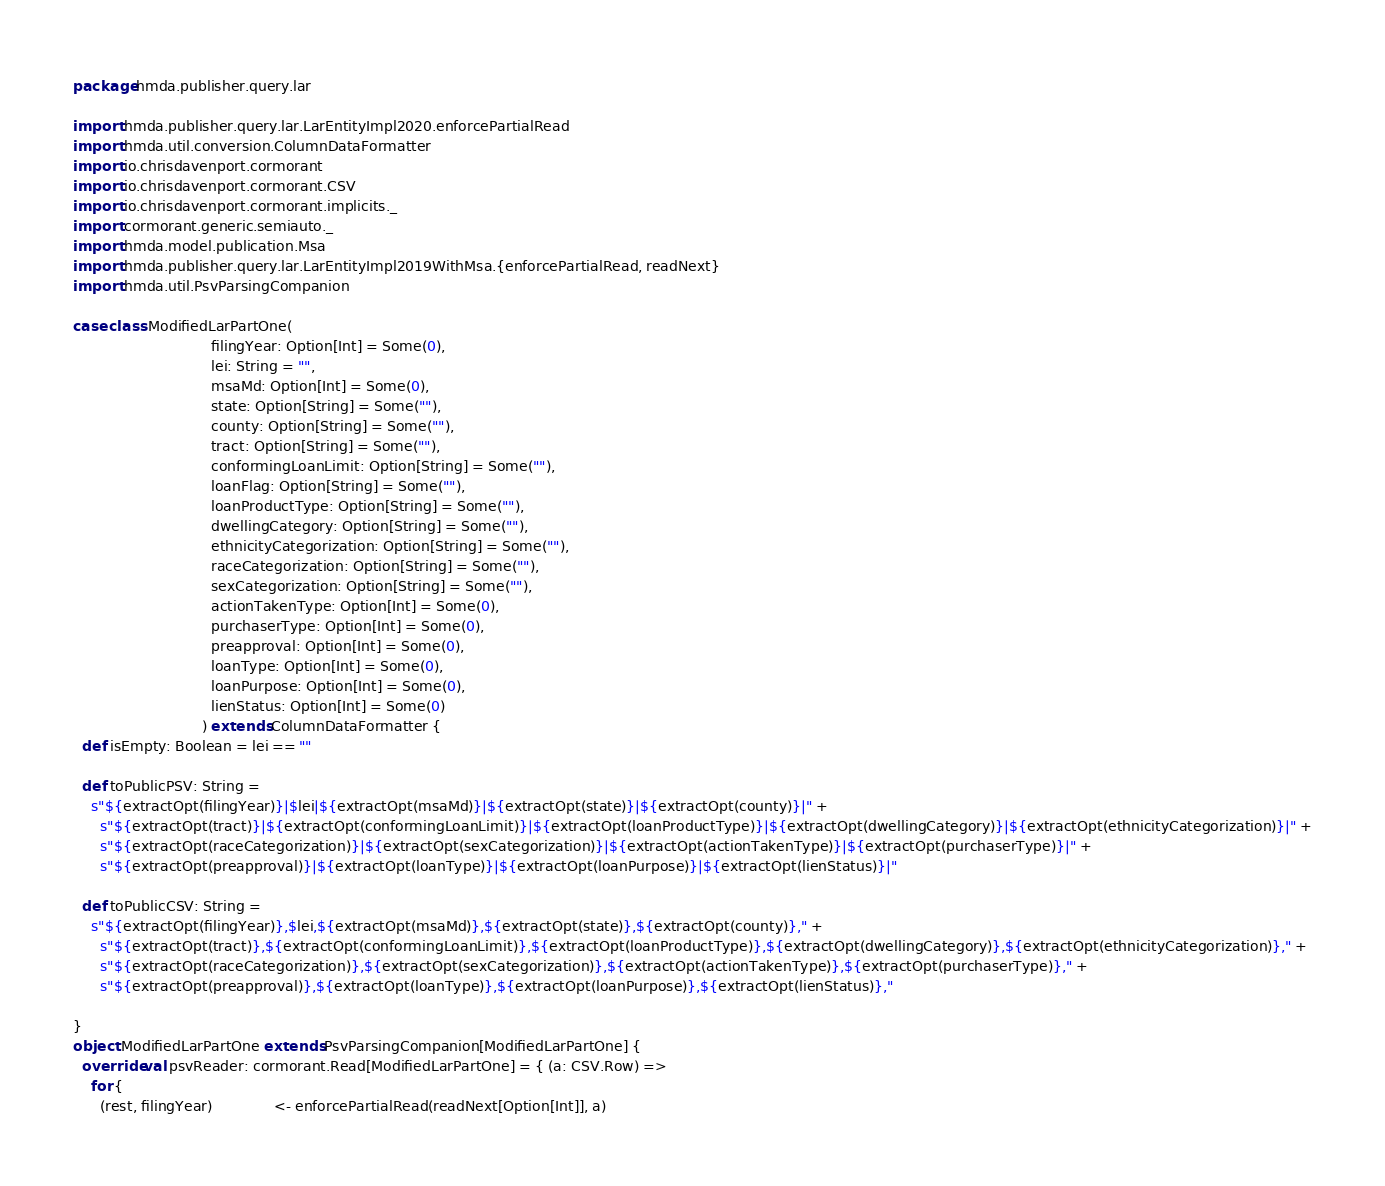<code> <loc_0><loc_0><loc_500><loc_500><_Scala_>package hmda.publisher.query.lar

import hmda.publisher.query.lar.LarEntityImpl2020.enforcePartialRead
import hmda.util.conversion.ColumnDataFormatter
import io.chrisdavenport.cormorant
import io.chrisdavenport.cormorant.CSV
import io.chrisdavenport.cormorant.implicits._
import cormorant.generic.semiauto._
import hmda.model.publication.Msa
import hmda.publisher.query.lar.LarEntityImpl2019WithMsa.{enforcePartialRead, readNext}
import hmda.util.PsvParsingCompanion

case class ModifiedLarPartOne(
                               filingYear: Option[Int] = Some(0),
                               lei: String = "",
                               msaMd: Option[Int] = Some(0),
                               state: Option[String] = Some(""),
                               county: Option[String] = Some(""),
                               tract: Option[String] = Some(""),
                               conformingLoanLimit: Option[String] = Some(""),
                               loanFlag: Option[String] = Some(""),
                               loanProductType: Option[String] = Some(""),
                               dwellingCategory: Option[String] = Some(""),
                               ethnicityCategorization: Option[String] = Some(""),
                               raceCategorization: Option[String] = Some(""),
                               sexCategorization: Option[String] = Some(""),
                               actionTakenType: Option[Int] = Some(0),
                               purchaserType: Option[Int] = Some(0),
                               preapproval: Option[Int] = Some(0),
                               loanType: Option[Int] = Some(0),
                               loanPurpose: Option[Int] = Some(0),
                               lienStatus: Option[Int] = Some(0)
                             ) extends ColumnDataFormatter {
  def isEmpty: Boolean = lei == ""

  def toPublicPSV: String =
    s"${extractOpt(filingYear)}|$lei|${extractOpt(msaMd)}|${extractOpt(state)}|${extractOpt(county)}|" +
      s"${extractOpt(tract)}|${extractOpt(conformingLoanLimit)}|${extractOpt(loanProductType)}|${extractOpt(dwellingCategory)}|${extractOpt(ethnicityCategorization)}|" +
      s"${extractOpt(raceCategorization)}|${extractOpt(sexCategorization)}|${extractOpt(actionTakenType)}|${extractOpt(purchaserType)}|" +
      s"${extractOpt(preapproval)}|${extractOpt(loanType)}|${extractOpt(loanPurpose)}|${extractOpt(lienStatus)}|"

  def toPublicCSV: String =
    s"${extractOpt(filingYear)},$lei,${extractOpt(msaMd)},${extractOpt(state)},${extractOpt(county)}," +
      s"${extractOpt(tract)},${extractOpt(conformingLoanLimit)},${extractOpt(loanProductType)},${extractOpt(dwellingCategory)},${extractOpt(ethnicityCategorization)}," +
      s"${extractOpt(raceCategorization)},${extractOpt(sexCategorization)},${extractOpt(actionTakenType)},${extractOpt(purchaserType)}," +
      s"${extractOpt(preapproval)},${extractOpt(loanType)},${extractOpt(loanPurpose)},${extractOpt(lienStatus)},"

}
object ModifiedLarPartOne extends PsvParsingCompanion[ModifiedLarPartOne] {
  override val psvReader: cormorant.Read[ModifiedLarPartOne] = { (a: CSV.Row) =>
    for {
      (rest, filingYear)              <- enforcePartialRead(readNext[Option[Int]], a)</code> 